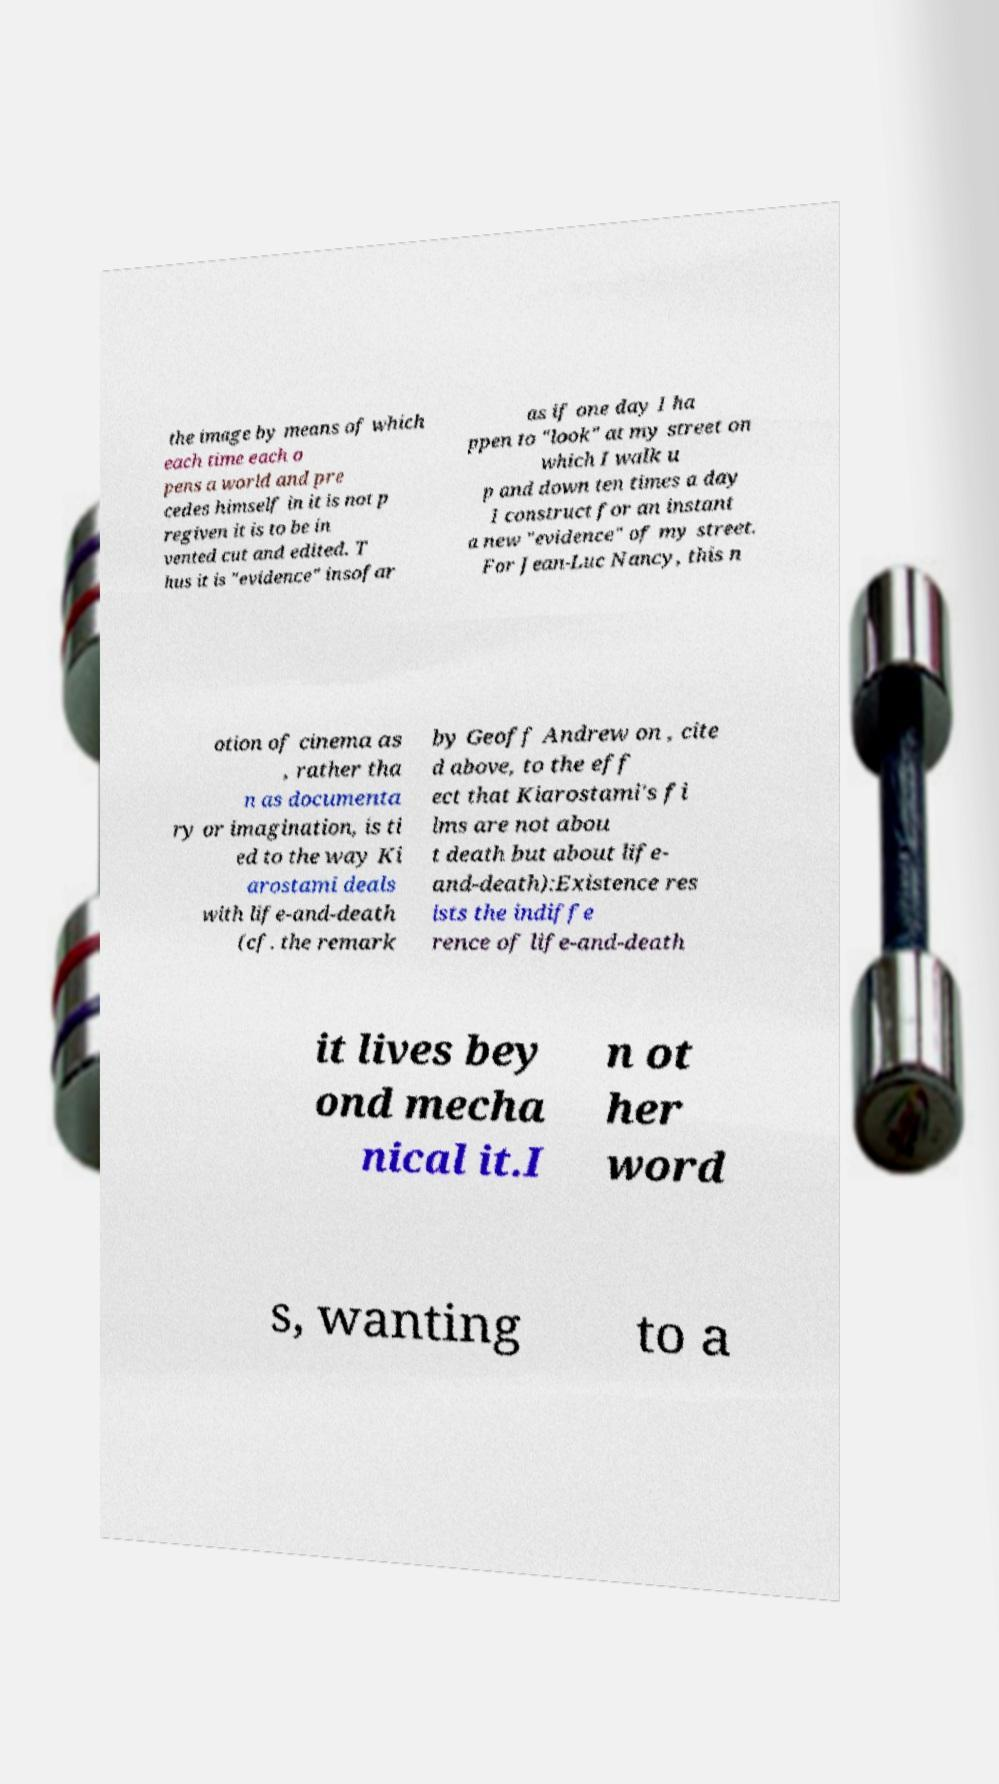What messages or text are displayed in this image? I need them in a readable, typed format. the image by means of which each time each o pens a world and pre cedes himself in it is not p regiven it is to be in vented cut and edited. T hus it is "evidence" insofar as if one day I ha ppen to "look" at my street on which I walk u p and down ten times a day I construct for an instant a new "evidence" of my street. For Jean-Luc Nancy, this n otion of cinema as , rather tha n as documenta ry or imagination, is ti ed to the way Ki arostami deals with life-and-death (cf. the remark by Geoff Andrew on , cite d above, to the eff ect that Kiarostami's fi lms are not abou t death but about life- and-death):Existence res ists the indiffe rence of life-and-death it lives bey ond mecha nical it.I n ot her word s, wanting to a 